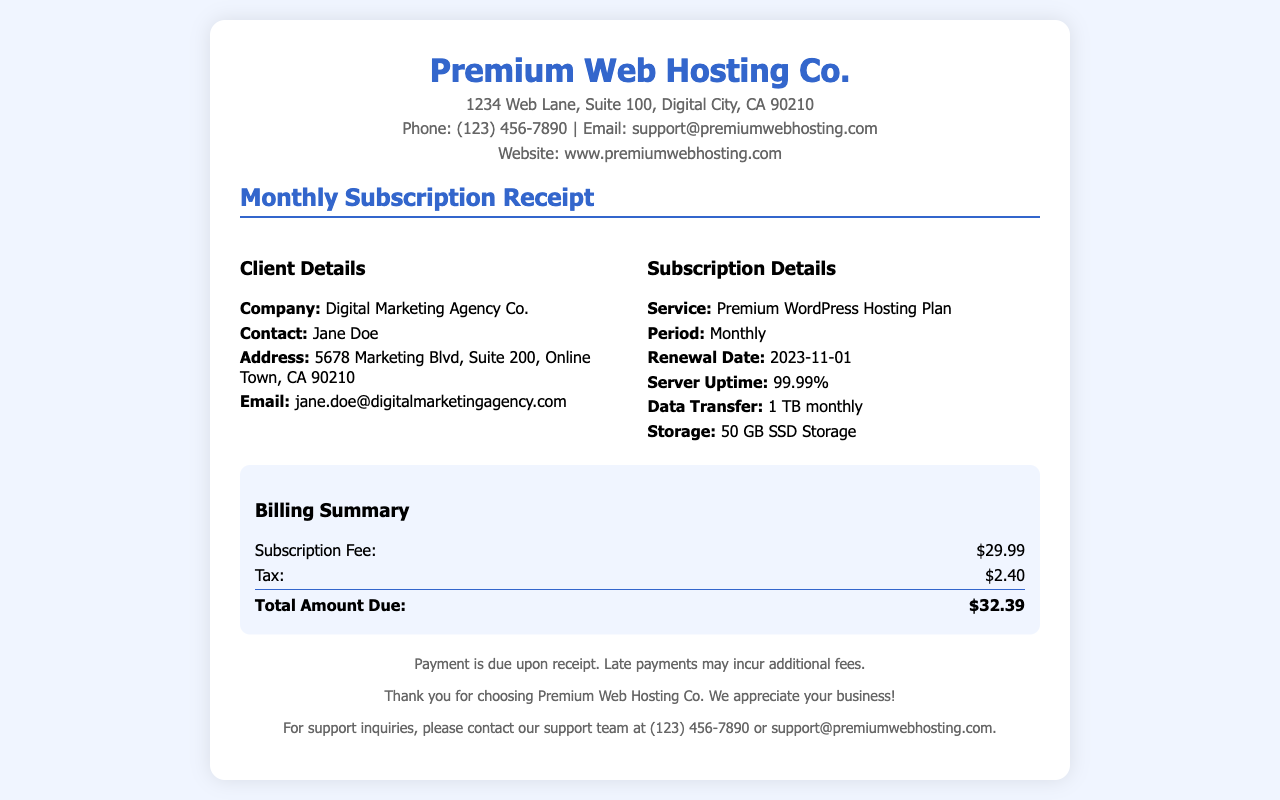what is the renewal date? The renewal date is specified in the document as the next due date for the subscription, which is 2023-11-01.
Answer: 2023-11-01 what is the storage capacity provided? The document mentions the storage capacity included in the subscription details, which is 50 GB SSD Storage.
Answer: 50 GB SSD Storage what is the subscription fee? The subscription fee for the service is detailed in the billing summary as being $29.99.
Answer: $29.99 what is the total amount due? The total amount due is calculated as the sum of the subscription fee and tax, stated in the billing section as $32.39.
Answer: $32.39 how much data transfer is included monthly? The monthly data transfer limit is given in the subscription details, which is 1 TB.
Answer: 1 TB what is the server uptime percentage? The document provides the server uptime percentage as a measure of reliability, indicated as 99.99%.
Answer: 99.99% who is the contact person for the client? The document lists the contact person for the client under client details as Jane Doe.
Answer: Jane Doe what is the tax amount charged? The tax amount charged is specified in the billing summary as $2.40.
Answer: $2.40 what type of service is being billed? The service provided is indicated in the subscription details, which is Premium WordPress Hosting Plan.
Answer: Premium WordPress Hosting Plan 